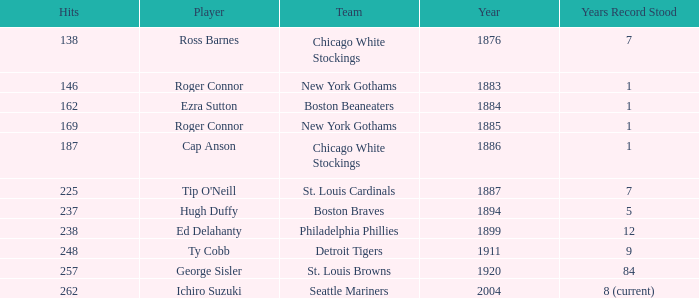Name the player with 238 hits and years after 1885 Ed Delahanty. 